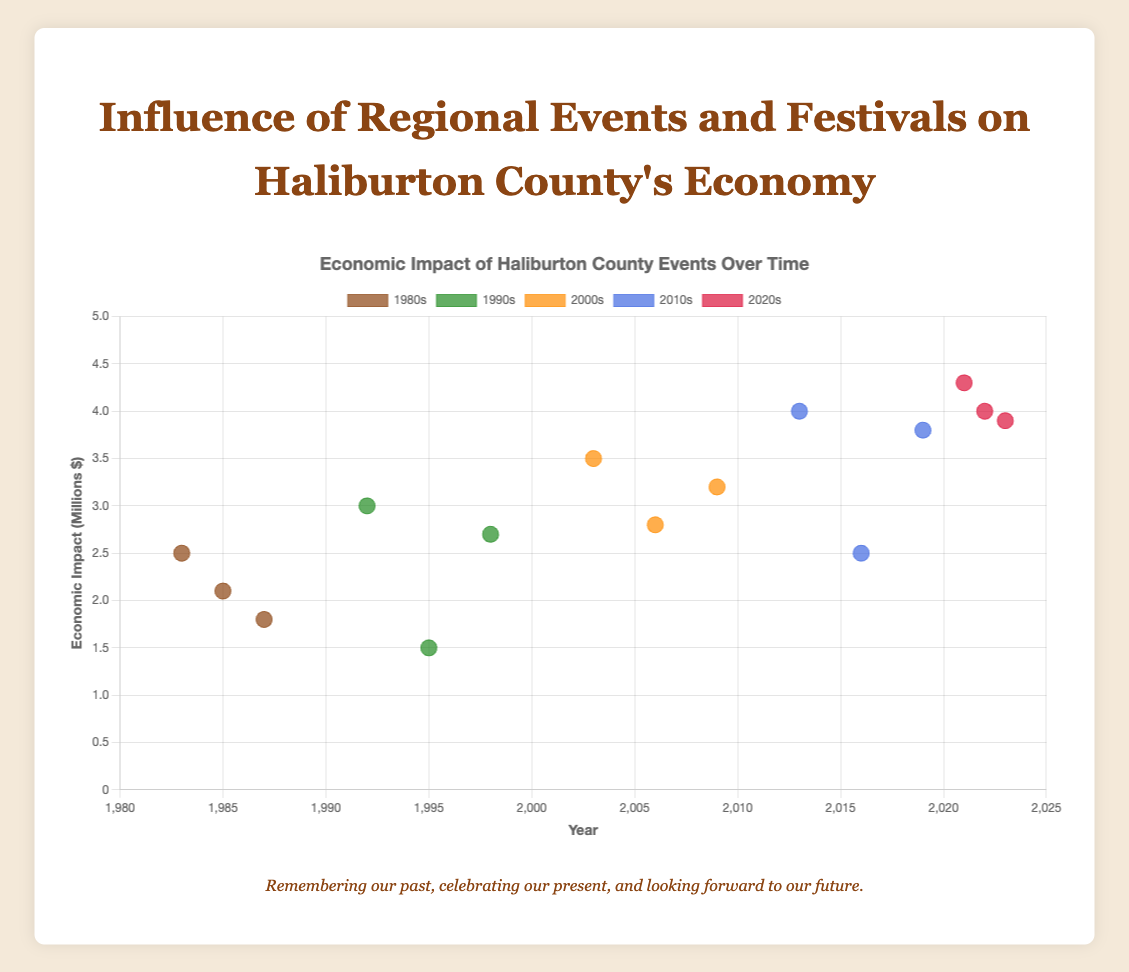Which event in the 1980s had the highest economic impact? The 1980s has three events: Haliburton Art and Craft Festival ($2.5M), Haliburton Forest Festival ($1.8M), and Rails End Gallery Exhibition ($2.1M). The highest economic impact of these three is Haliburton Art and Craft Festival at $2.5M.
Answer: Haliburton Art and Craft Festival How does the economic impact of the Haliburton Art and Craft Festival in the 2010s compare to that in the 1980s? In the 1980s, the economic impact of the Haliburton Art and Craft Festival was $2.5M, while in the 2010s, it was $4.0M. By comparing these values, it shows that the economic impact increased by $1.5M from the 1980s to the 2010s.
Answer: Increased by $1.5M What is the average economic impact of the events in the 1990s? The economic impacts of the events in the 1990s are: $3.0M, $1.5M, and $2.7M. Adding them up gives 3.0 + 1.5 + 2.7 = $7.2M. Dividing by the number of events (3), the average is 7.2 / 3 = $2.4M.
Answer: $2.4M Which decade shows the highest average economic impact across all events? Calculating the average economic impact per decade: 1980s ($2.13M), 1990s ($2.4M), 2000s ($3.17M), 2010s ($3.43M), and 2020s ($4.07M). The decade with the highest average is the 2020s at $4.07M.
Answer: 2020s What is the economic impact difference between the Haliburton County Fair and Winter Folk Camp in the 2010s? The economic impact of the Haliburton County Fair in the 2010s is $3.8M, and for the Winter Folk Camp, it is $2.5M. The difference is 3.8 - 2.5 = $1.3M.
Answer: $1.3M How many events in total are depicted across all decades? Counting the number of events listed for each decade: 1980s (3), 1990s (3), 2000s (3), 2010s (3), and 2020s (3). Adding them up, there are 3 + 3 + 3 + 3 + 3 = 15 events in total.
Answer: 15 From which year onwards can we see events with an economic impact of more than $4.0M? The chart shows that events with an economic impact of above $4.0M start appearing in the 2020s with Haliburton Highlands Craft Brewery Festival ($4.3M) and Hike Haliburton Festival ($4.0M).
Answer: 2020s Compare the economic impact growth of the Forest Festival over time. The Forest Festival has three recorded economic impacts: $1.8M (1987), $3.2M (2009), and $3.9M (2023). The economic impact has grown from $1.8M to $3.2M (an increase of $1.4M), and from $3.2M to $3.9M (an increase of $0.7M), showing steady growth over time.
Answer: Steady growth 